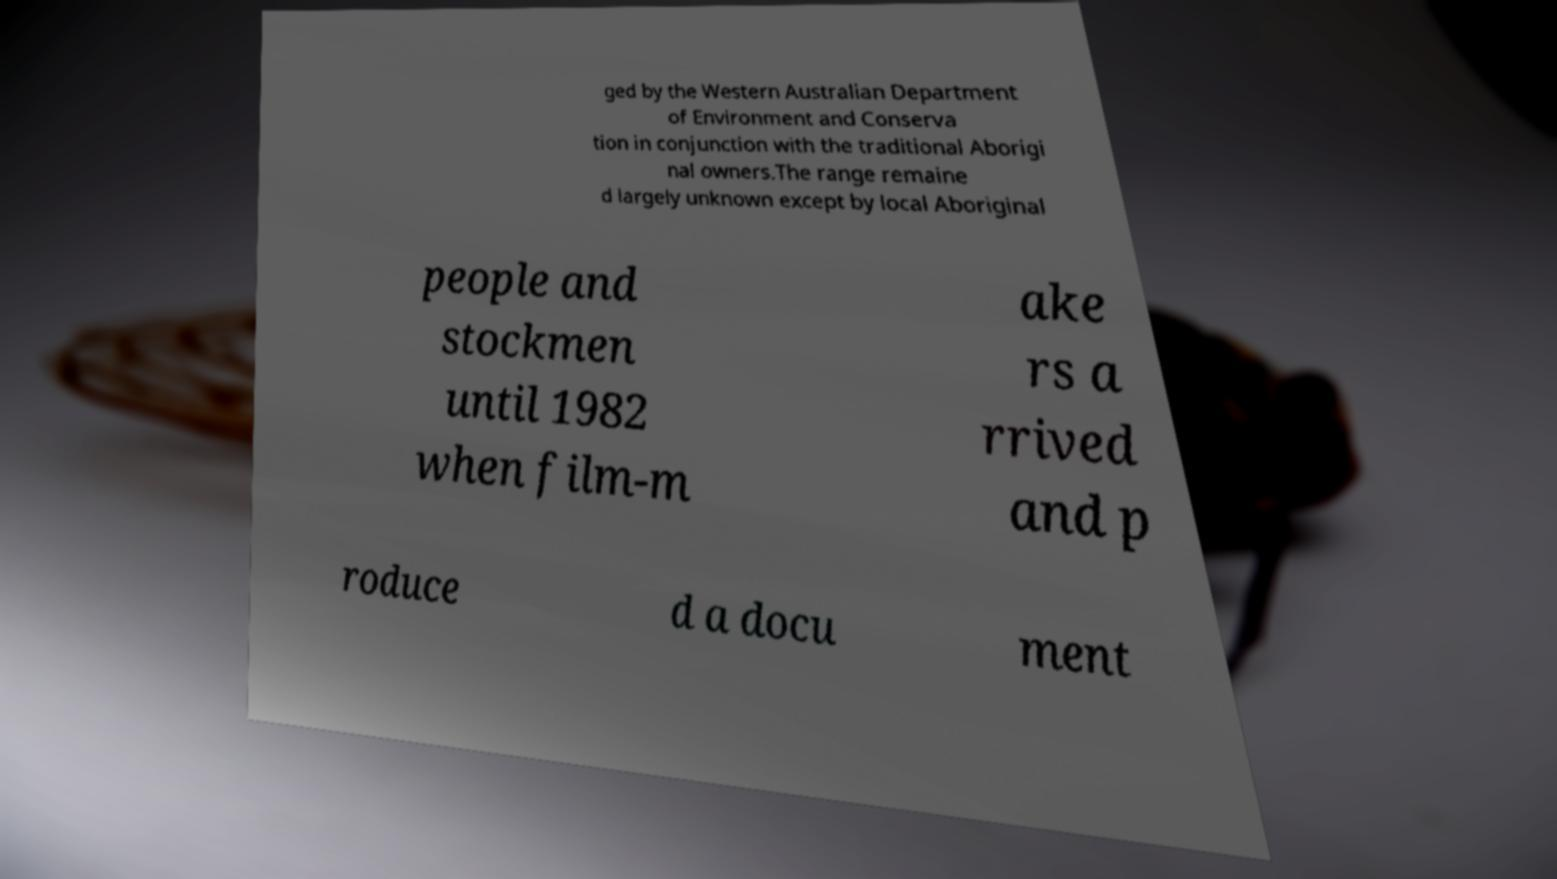I need the written content from this picture converted into text. Can you do that? ged by the Western Australian Department of Environment and Conserva tion in conjunction with the traditional Aborigi nal owners.The range remaine d largely unknown except by local Aboriginal people and stockmen until 1982 when film-m ake rs a rrived and p roduce d a docu ment 